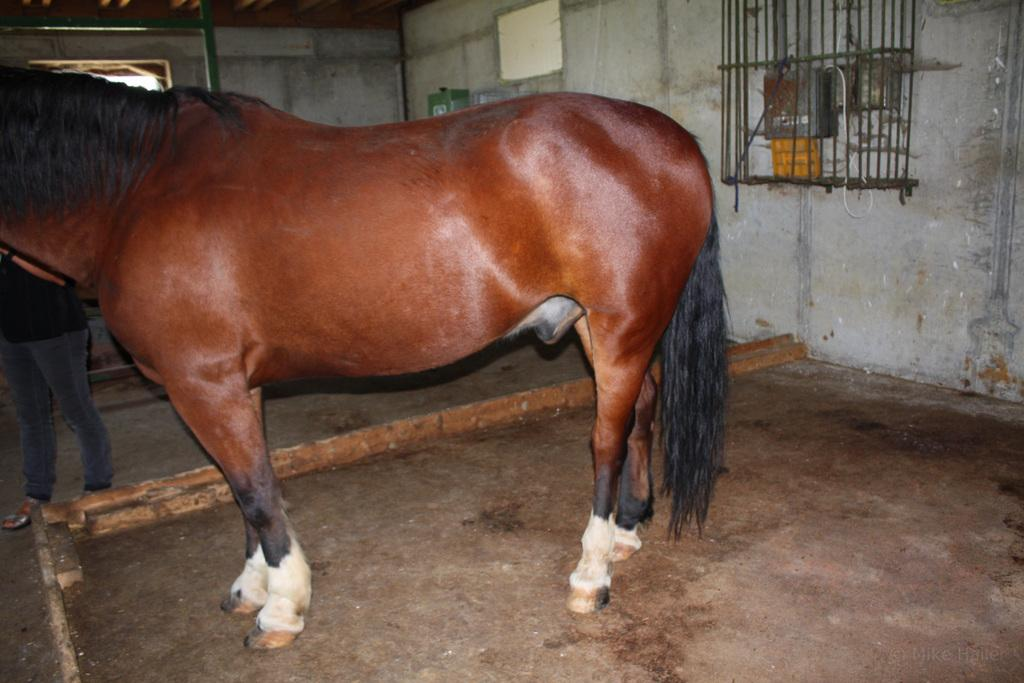What animal is standing on the ground in the image? There is a horse standing on the ground in the image. Who or what is on the left side of the image? There is a person on the left side of the image. What can be seen on the wall in the image? There are objects visible on the wall in the image. What is in the background of the image? There is a pole in the background of the image. What type of rhythm is the horse displaying in the image? There is no indication of rhythm in the image; it simply shows a horse standing on the ground. What force is being applied to the person on the left side of the image? There is no indication of force being applied to the person in the image; they are simply standing on the left side. 